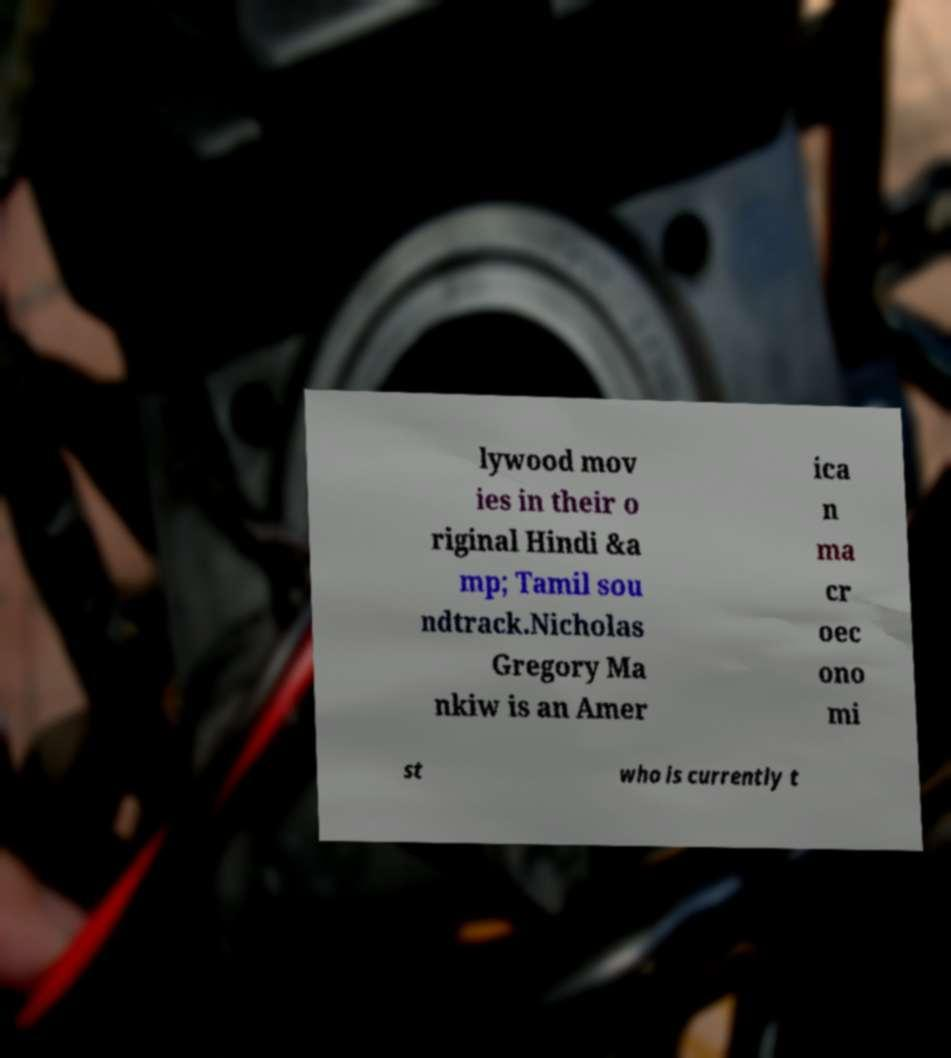There's text embedded in this image that I need extracted. Can you transcribe it verbatim? lywood mov ies in their o riginal Hindi &a mp; Tamil sou ndtrack.Nicholas Gregory Ma nkiw is an Amer ica n ma cr oec ono mi st who is currently t 